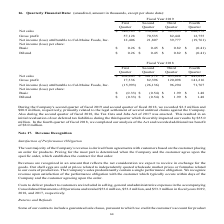Looking at Cal Maine Foods's financial data, please calculate: What is the total net sales for the year ending 2019? Based on the calculation: 340,583 + 356,040 + 383,993 + 280,572, the result is 1361188 (in thousands). This is based on the information: "ter Quarter Quarter Quarter Net sales $ 340,583 $ 356,040 $ 383,993 $ 280,572 Gross profit 57,128 70,535 82,441 12,755 Net income (loss) attributable to Cal- ourth Quarter Quarter Quarter Quarter Net ..." The key data points involved are: 280,572, 340,583, 356,040. Also, can you calculate: What is the percentage increase / (decrease) in the diluted net income (loss) per share from 2019 to 2018? To answer this question, I need to perform calculations using the financial data. The calculation is: 0.82 / 1.99 - 1, which equals -58.79 (percentage). This is based on the information: "et income (loss) per share: Basic $ 0.26 $ 0.45 $ 0.82 $ (0.41) Diluted $ 0.26 $ 0.45 $ 0.82 $ (0.41) ncome (loss) per share: Basic $ (0.33) $ (0.54) $ 1.99 $ 1.48 Diluted $ (0.33) $ (0.54) $ 1.99 $ 1..." The key data points involved are: 0.82, 1.99. Also, can you calculate: What is the increase in the gross profit in 2019 from 1st quarter to 2nd quarter? Based on the calculation: 70,535 - 57,128, the result is 13407 (in thousands). This is based on the information: "40,583 $ 356,040 $ 383,993 $ 280,572 Gross profit 57,128 70,535 82,441 12,755 Net income (loss) attributable to Cal-Maine Foods, Inc. 12,406 21,807 39,777 ( $ 356,040 $ 383,993 $ 280,572 Gross profit ..." The key data points involved are: 57,128, 70,535. Also, What was the additional tax benefit recorded in 2018? According to the financial document, 8.0 (in millions). The relevant text states: "f the Act and recorded additional tax benefit of $8.0 million...." Also, When was the Tax Cuts and Jobs Act of 2017 enacted? According to the financial document, 2018. The relevant text states: "Fiscal Year 2018 First Second Third Fourth Quarter Quarter Quarter Quarter Net sales $ 262,845 $ 361,172 $ 435,820 $ Fiscal Year 2018 First Second Third Fourth Quarter Quarter Quarter Quarter Net sale..." Also, What was the impact of initial revaluation of our deferred tax liabilities during the third quarter? favorably impacted our results by $35.0 million. (in millions). The document states: "red tax liabilities during the third quarter which favorably impacted our results by $35.0 million. In the fourth quarter of fiscal 2018, we completed..." 